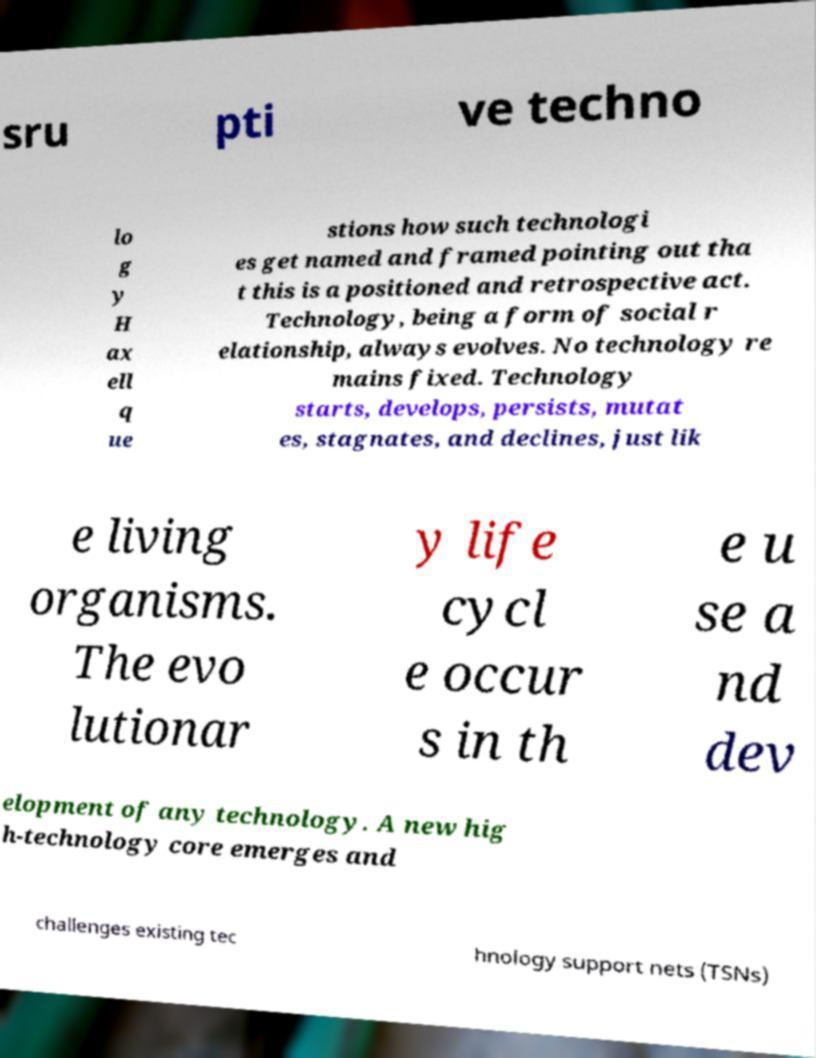Please identify and transcribe the text found in this image. sru pti ve techno lo g y H ax ell q ue stions how such technologi es get named and framed pointing out tha t this is a positioned and retrospective act. Technology, being a form of social r elationship, always evolves. No technology re mains fixed. Technology starts, develops, persists, mutat es, stagnates, and declines, just lik e living organisms. The evo lutionar y life cycl e occur s in th e u se a nd dev elopment of any technology. A new hig h-technology core emerges and challenges existing tec hnology support nets (TSNs) 